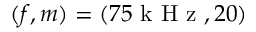<formula> <loc_0><loc_0><loc_500><loc_500>( f , m ) = ( 7 5 k H z , 2 0 )</formula> 